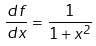<formula> <loc_0><loc_0><loc_500><loc_500>\frac { d f } { d x } = \frac { 1 } { 1 + x ^ { 2 } }</formula> 